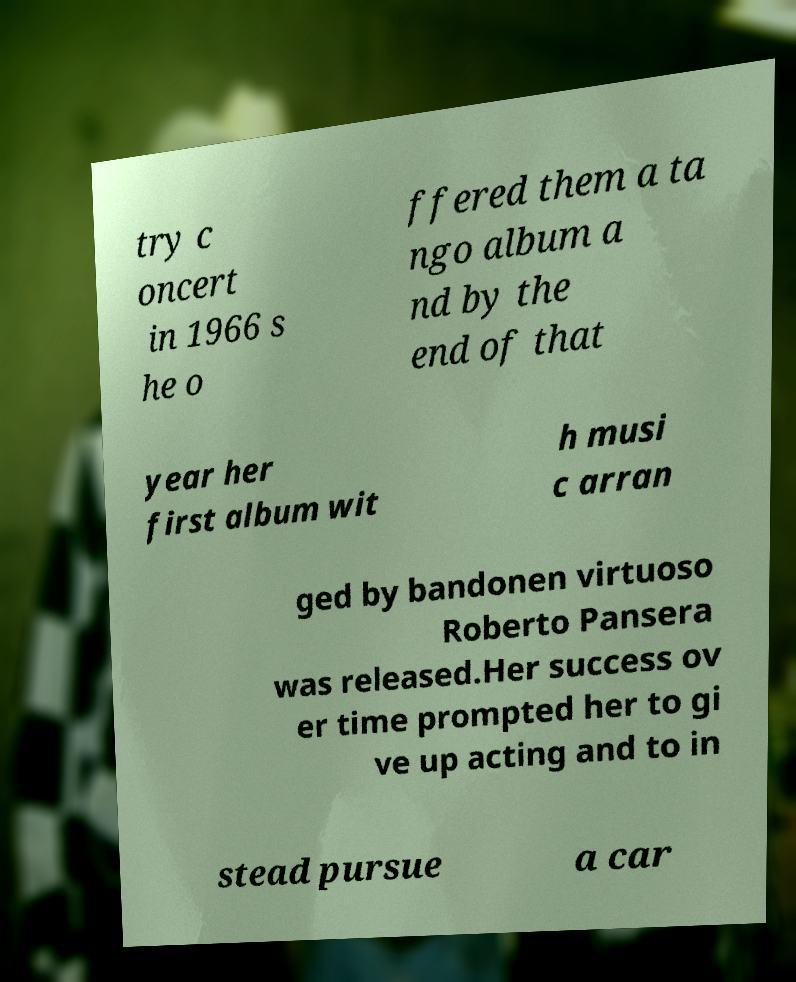Please read and relay the text visible in this image. What does it say? try c oncert in 1966 s he o ffered them a ta ngo album a nd by the end of that year her first album wit h musi c arran ged by bandonen virtuoso Roberto Pansera was released.Her success ov er time prompted her to gi ve up acting and to in stead pursue a car 